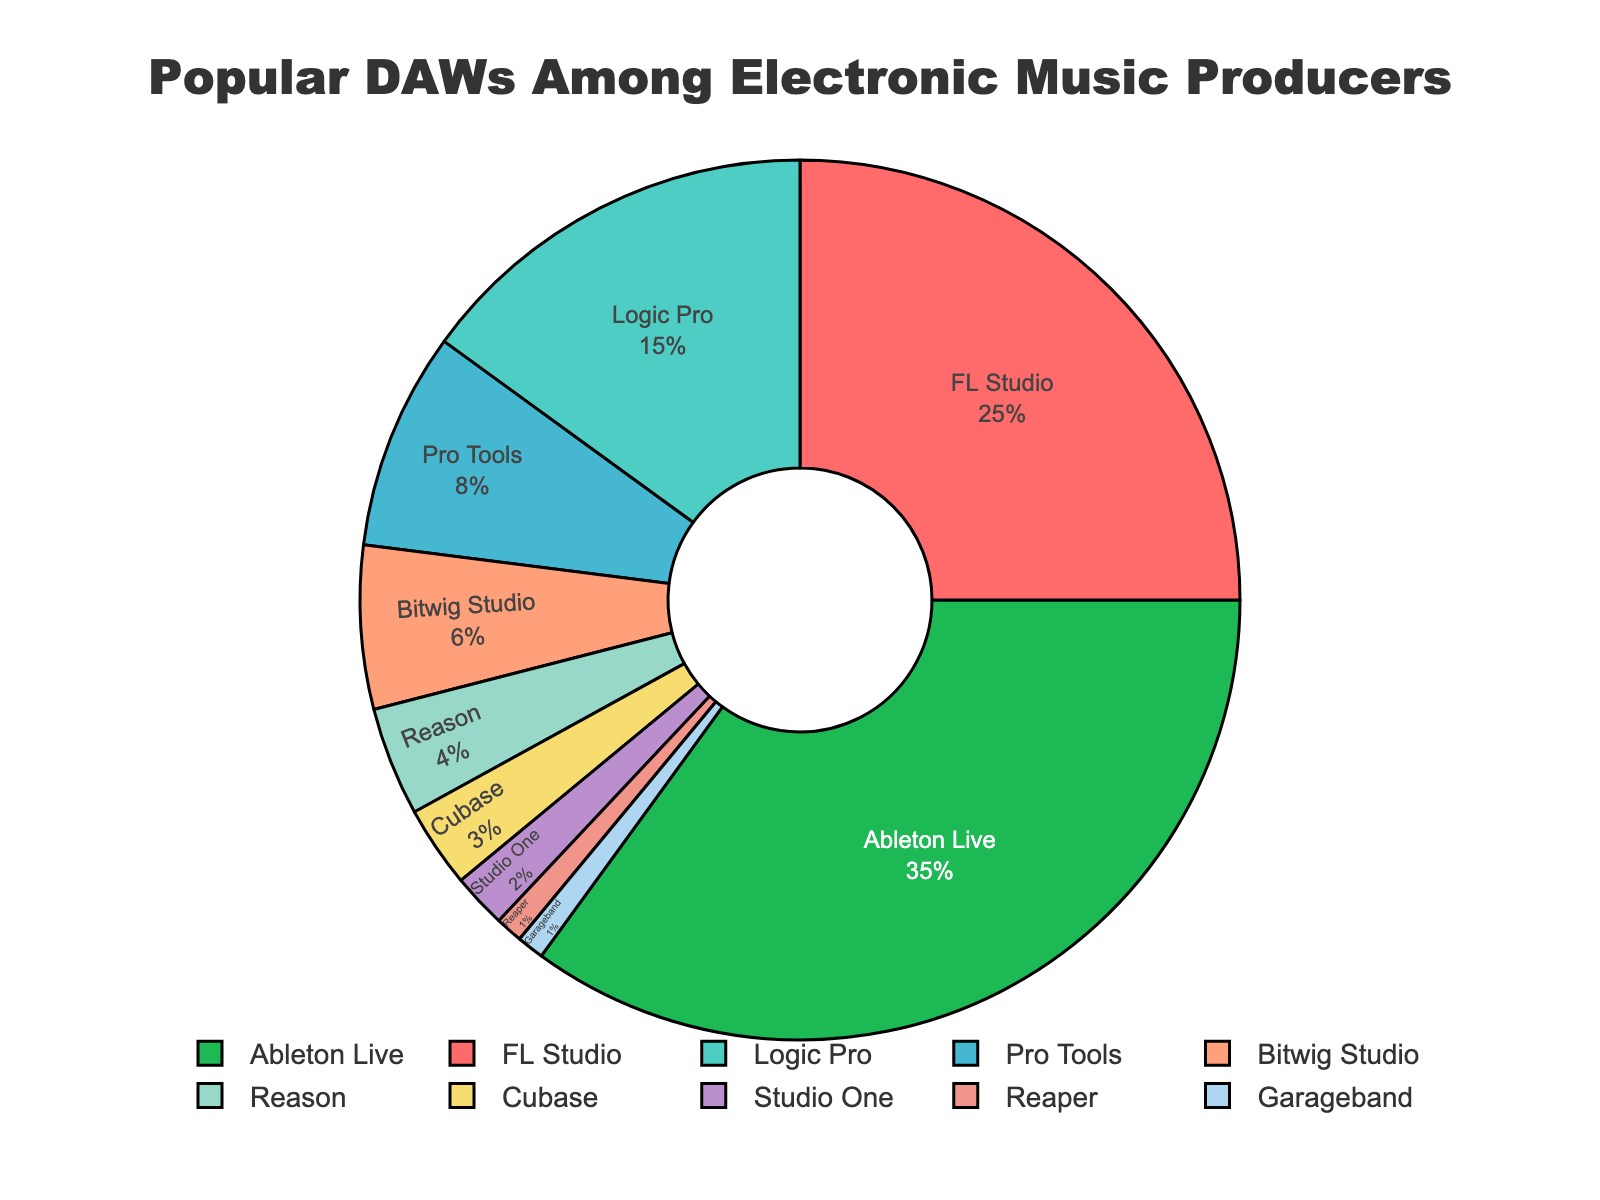What percentage of electronic music producers use Ableton Live? By looking at the pie chart, the label shows that Ableton Live is used by 35% of electronic music producers.
Answer: 35% What is the sum of the percentages of producers using Logic Pro and Pro Tools? Logic Pro has 15%, and Pro Tools has 8%. Summing them up gives 15% + 8% = 23%.
Answer: 23% Which DAW is used by fewer producers – Bitwig Studio or Reason? The pie chart indicates that Bitwig Studio is used by 6%, while Reason is used by 4%. Since 4% is less than 6%, Reason is used by fewer producers.
Answer: Reason What is the combined percentage for DAWs used by 3% or fewer producers? The DAWs used by 3% or fewer producers are Cubase (3%), Studio One (2%), Reaper (1%), and Garageband (1%). Summing their percentages gives 3% + 2% + 1% + 1% = 7%.
Answer: 7% Which DAW takes up the largest section of the pie chart, and what color is it represented by? The largest section of the pie chart represents Ableton Live with 35%, and it is shown in green.
Answer: Ableton Live, green What is the difference in percentage between producers using FL Studio and Logic Pro? FL Studio is used by 25%, and Logic Pro is used by 15%. The difference is 25% - 15% = 10%.
Answer: 10% If you combined the percentage of producers using Ableton Live and FL Studio, would it be more than 50%? Ableton Live is used by 35%, and FL Studio is used by 25%. Their combined percentage is 35% + 25% = 60%, which is more than 50%.
Answer: Yes Which DAWs are represented by shades of blue, and what are their respective percentages? Pro Tools is represented by light blue with 8%, and Garageband is represented by a pale blue with 1%.
Answer: Pro Tools: 8%, Garageband: 1% What percentage of producers use either Bitwig Studio or Studio One? Bitwig Studio is used by 6%, and Studio One is used by 2%. Their combined percentage is 6% + 2% = 8%.
Answer: 8% By how much does the usage percentage of Ableton Live exceed that of Cubase? Ableton Live is used by 35%, and Cubase is used by 3%. The difference is 35% - 3% = 32%.
Answer: 32% 